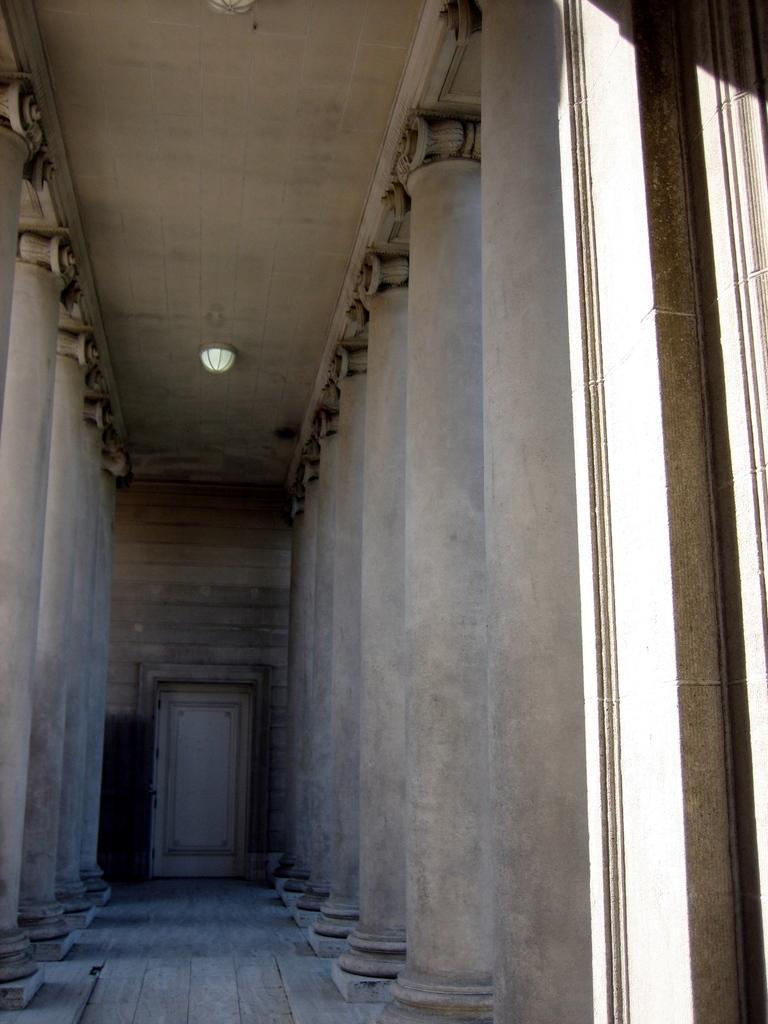Can you describe this image briefly? In this picture we can see the floor, pillars, door, wall and in the background we can see the light, ceiling. 